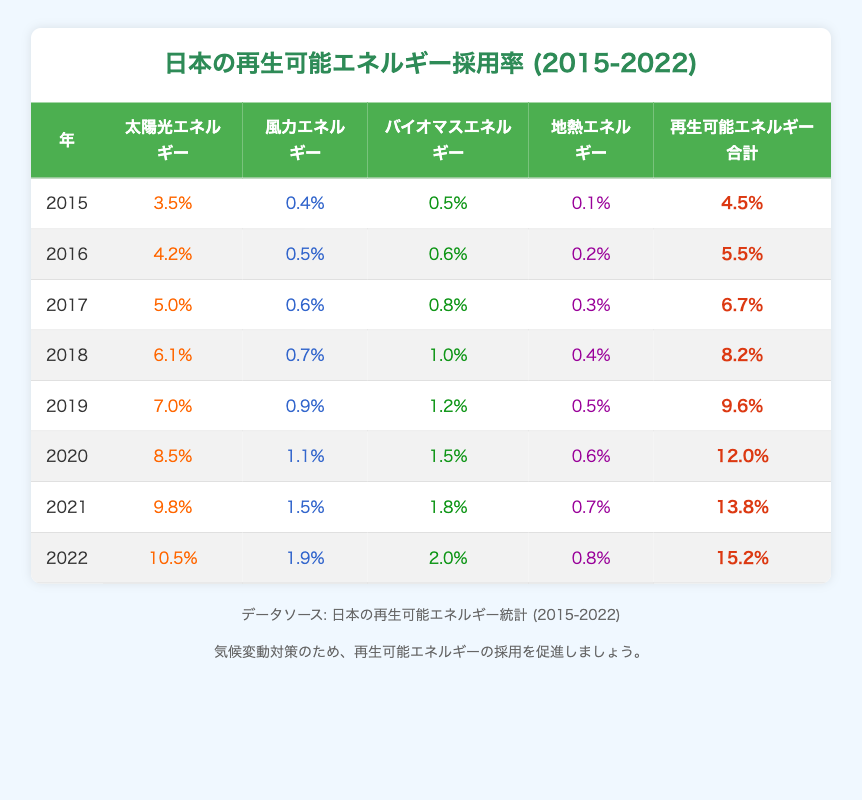What was the total renewable energy adoption rate in 2020? In the table, for the year 2020, the Total Renewable value is given as 12.0%.
Answer: 12.0% Which renewable energy type had the highest adoption rate in 2022? Looking at the table for the year 2022, the Solar Energy value is 10.5%, which is higher than other values: Wind (1.9%), Biomass (2.0%), and Geothermal (0.8%).
Answer: Solar Energy Did the adoption rate of biomass energy increase from 2015 to 2022? The values for Biomass Energy are 0.5% in 2015 and 2.0% in 2022. Since 2.0% > 0.5%, the adoption rate did increase.
Answer: Yes What was the percentage increase in total renewable energy adoption from 2015 to 2022? The Total Renewable value in 2015 was 4.5%, and in 2022 it was 15.2%. The difference is 15.2% - 4.5% = 10.7%. To find the percentage increase, we calculate (10.7% / 4.5%) * 100 ≈ 237.8%.
Answer: Approximately 237.8% Is the renewable energy adoption rate higher in 2021 than in 2020? The Total Renewable value in 2021 is 13.8% and in 2020 it's 12.0%. Since 13.8% > 12.0%, 2021 has a higher rate.
Answer: Yes What is the average renewable energy adoption rate for the years 2019 to 2022? The total adoption rates for these years are: 2019 (9.6%), 2020 (12.0%), 2021 (13.8%), and 2022 (15.2%). The sum is 9.6% + 12.0% + 13.8% + 15.2% = 50.6%. There are 4 years, hence the average is 50.6% / 4 = 12.65%.
Answer: 12.65% Which year saw the lowest adoption of wind energy? From the table, the Wind Energy values are as follows: 0.4% (2015), 0.5% (2016), 0.6% (2017), 0.7% (2018), 0.9% (2019), 1.1% (2020), 1.5% (2021), and 1.9% (2022). The lowest is 0.4% in 2015.
Answer: 2015 How much did solar energy adoption grow from 2016 to 2022? The Solar Energy rate in 2016 is 4.2%, and in 2022 it is 10.5%. The growth is 10.5% - 4.2% = 6.3%.
Answer: 6.3% 